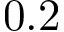Convert formula to latex. <formula><loc_0><loc_0><loc_500><loc_500>0 . 2</formula> 